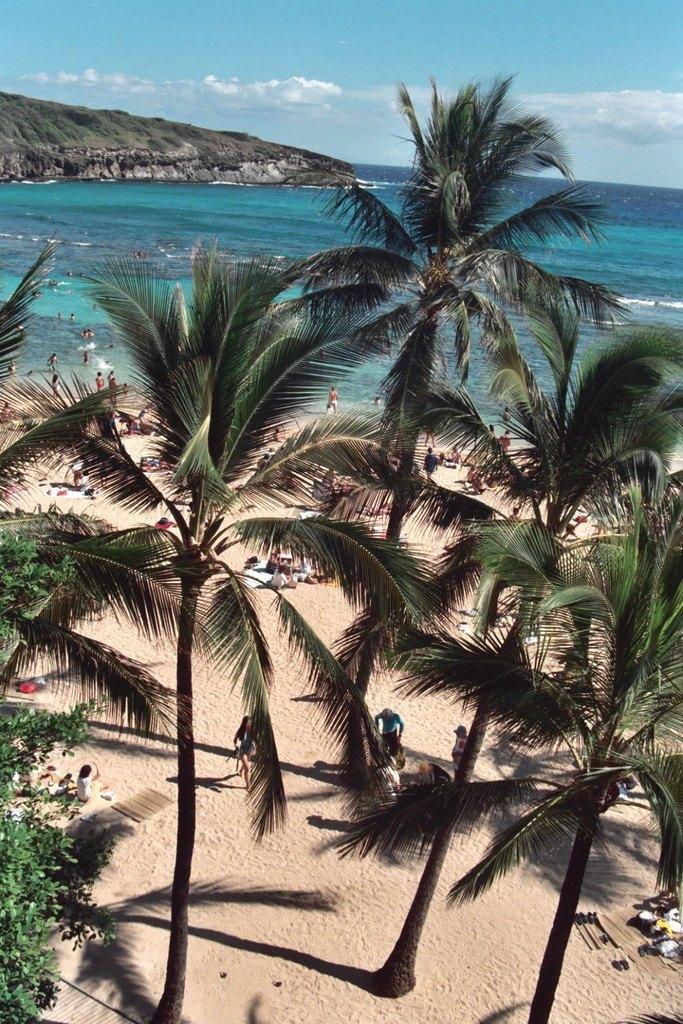In one or two sentences, can you explain what this image depicts? In this image there is the sky towards the top of the image, there are clouds in the sky, there is a mountain towards the left of the image, there is water, there are group of persons, there is sand, there are trees. 